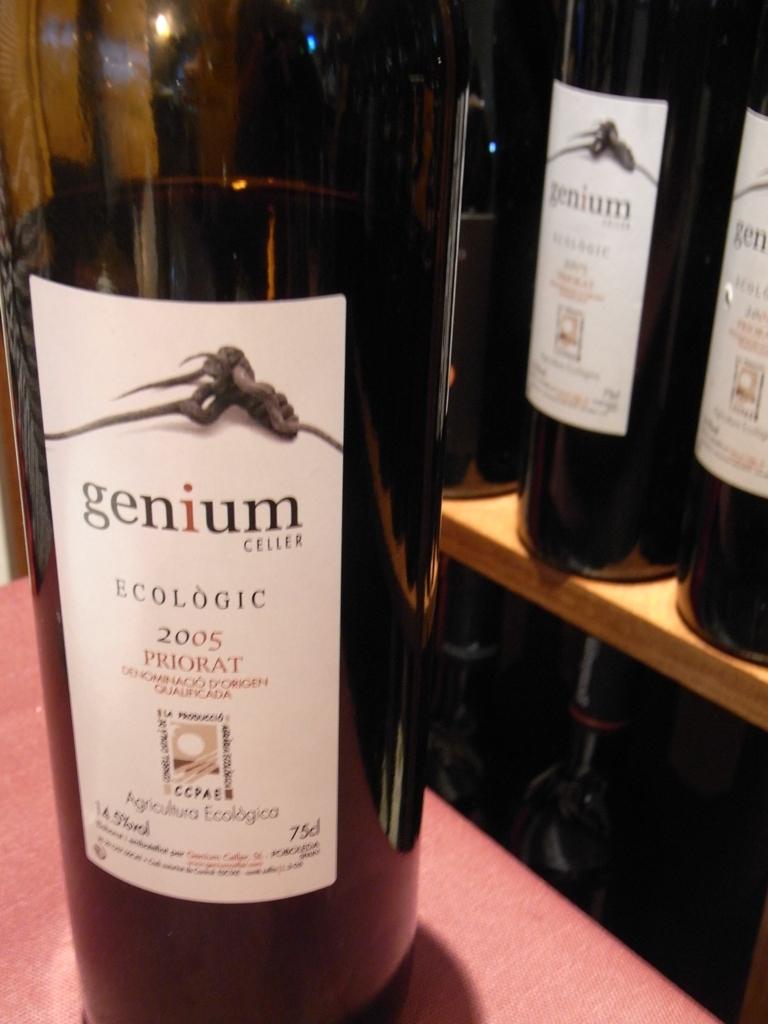What year was this wine made?
Provide a short and direct response. 2005. What is the name of this brand of wine?
Offer a very short reply. Genium. 